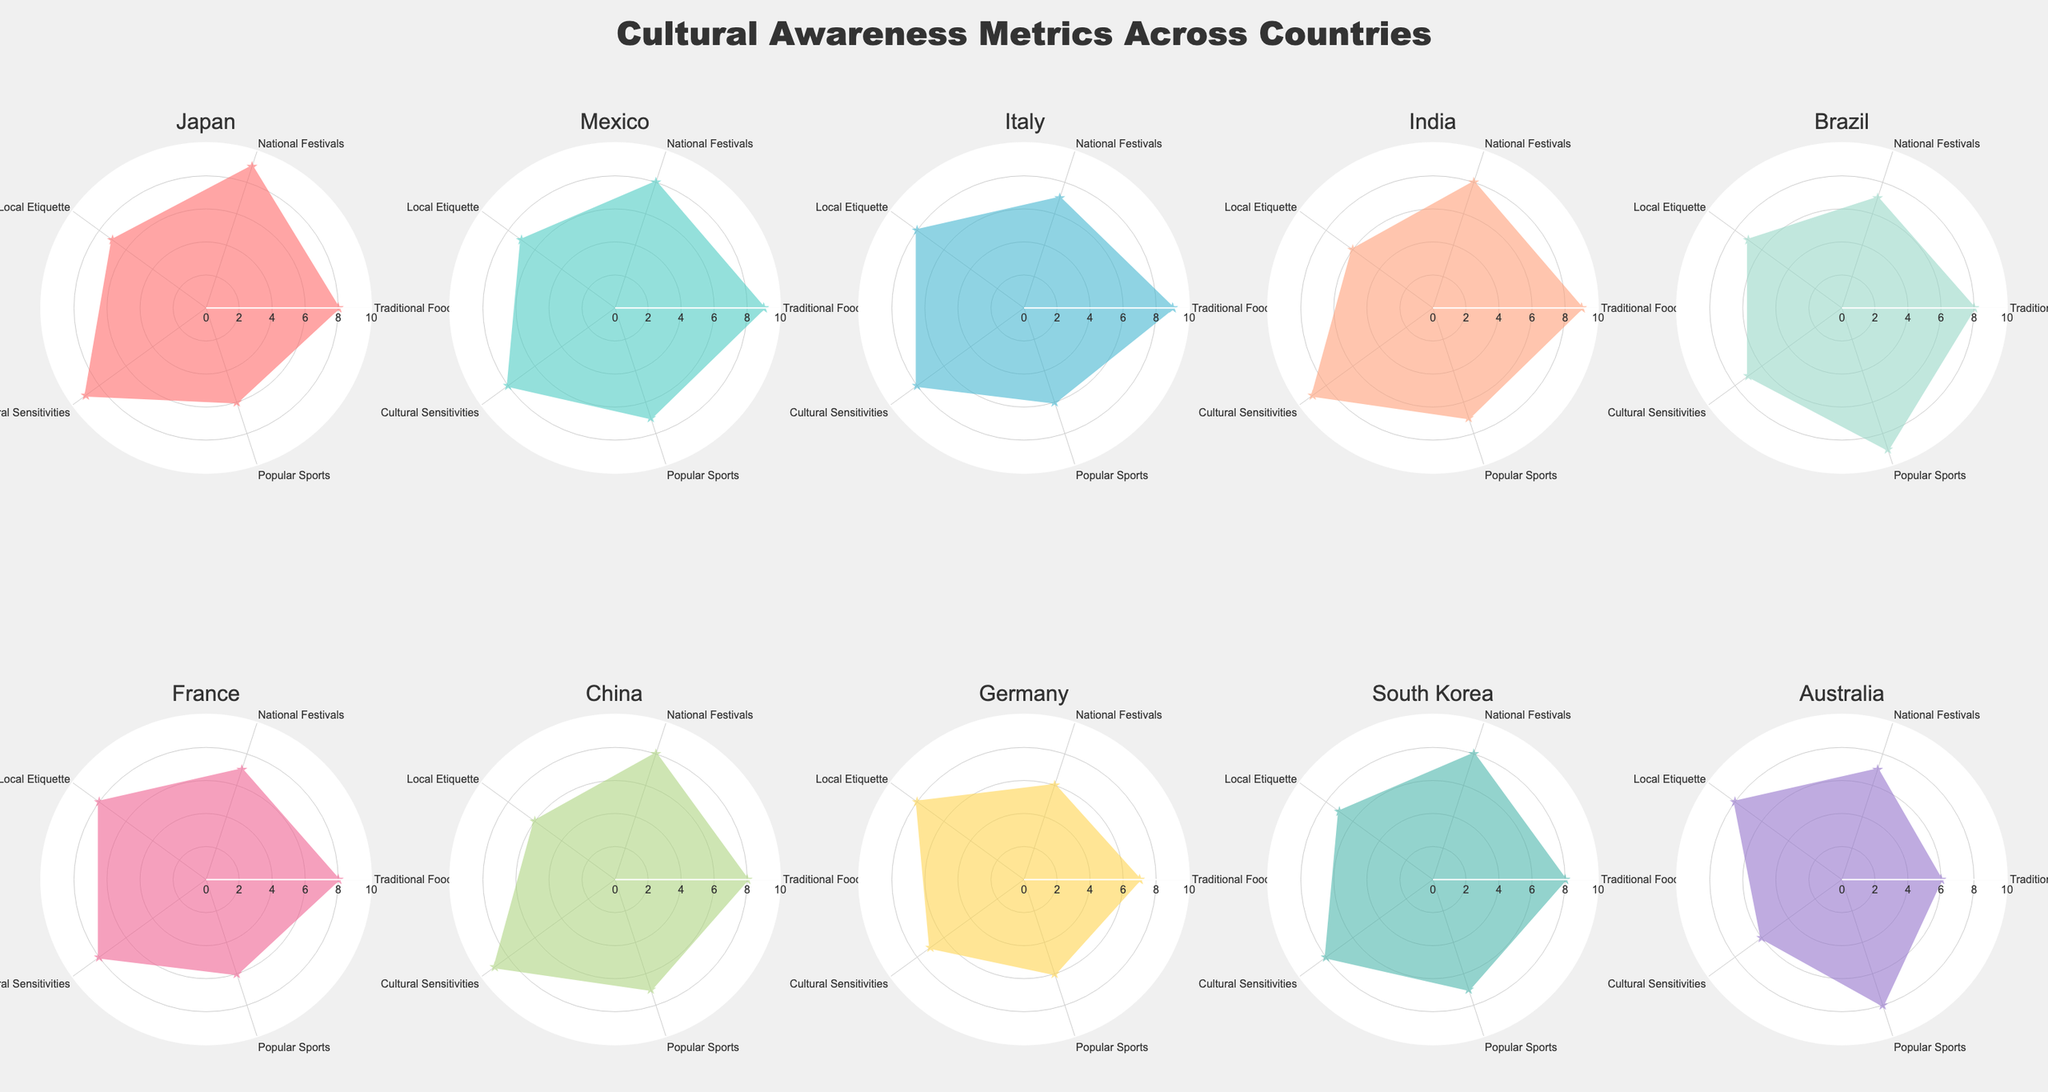what is the title of the figure? The title is located at the top center of the figure. It’s typically styled in a larger font size to distinguish it from other text elements.
Answer: Cultural Awareness Metrics Across Countries Which country has the highest score for Traditional Food? Look at the radar plot for each country and identify the plot with the highest value under the "Traditional Food" metric. Mexico, Italy, and India all have the highest values of 9.
Answer: Mexico, Italy, India Which country has the lowest score in Local Etiquette? Observe each radar plot and compare the values specifically for the "Local Etiquette" metric. Australia and China both have the lowest values, which is 6.
Answer: Australia, China What’s the average score for National Festivals across all countries? First, note the values for National Festivals for each country: 9, 8, 7, 8, 7, 7, 8, 6, 8, and 7. Sum these values and then divide by the number of countries (10). The sum is 75, and the average is 75/10.
Answer: 7.5 Which country shows the greatest variation across the five metrics? Examine the radar plots and identify the country with the widest range between its highest and lowest values. For instance, Australia shows a variation from 6 to 8.
Answer: Australia Compared to Germany, does France have a better score in Popular Sports? Look at the radar plots for both Germany and France and compare their scores in the Popular Sports category. France has 6, Germany has 6.
Answer: No Which country has the most balanced scores across all metrics? Look for a radar plot with values that are closest to each other, indicating minimal variance across the metrics. Italy appears balanced with values around 7-9.
Answer: Italy How many countries have a score of 8 in National Festivals? Count the radar plots where the National Festivals category shows a score of 8. The countries are Mexico, India, China, and South Korea.
Answer: 4 If you average the Popular Sports scores of Brazil, Italy, and South Korea, what value do you get? First, add the Popular Sports scores for Brazil (9), Italy (6), and South Korea (7). The sum is 22. Then, divide by the number of countries (3).
Answer: 7.33 What is the highest score for Cultural Sensitivities? Identify the highest value in the Cultural Sensitivities category across all radar plots. The highest value noted is 9, found in Japan, India, and China.
Answer: 9 